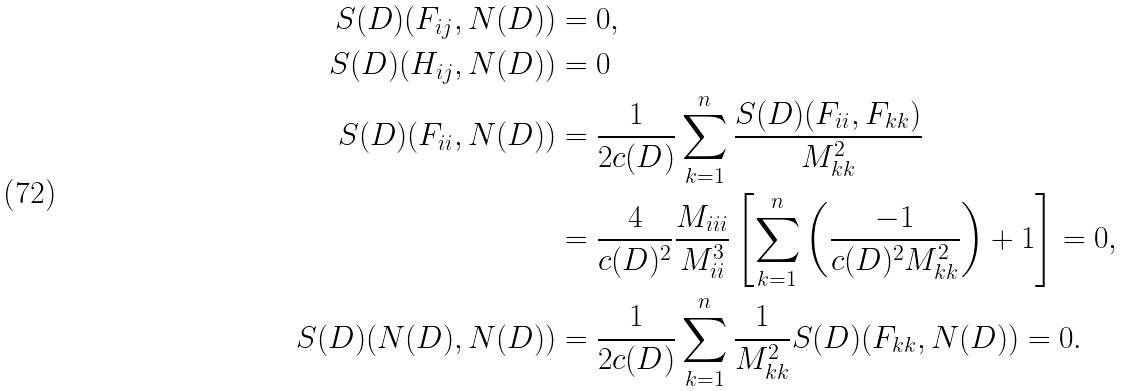<formula> <loc_0><loc_0><loc_500><loc_500>S ( D ) ( F _ { i j } , N ( D ) ) & = 0 , \\ S ( D ) ( H _ { i j } , N ( D ) ) & = 0 \\ S ( D ) ( F _ { i i } , N ( D ) ) & = \frac { 1 } { 2 c ( D ) } \sum _ { k = 1 } ^ { n } \frac { S ( D ) ( F _ { i i } , F _ { k k } ) } { M _ { k k } ^ { 2 } } \\ & = \frac { 4 } { c ( D ) ^ { 2 } } \frac { M _ { i i i } } { M _ { i i } ^ { 3 } } \left [ \sum _ { k = 1 } ^ { n } \left ( \frac { - 1 } { c ( D ) ^ { 2 } M _ { k k } ^ { 2 } } \right ) + 1 \right ] = 0 , \\ S ( D ) ( N ( D ) , N ( D ) ) & = \frac { 1 } { 2 c ( D ) } \sum _ { k = 1 } ^ { n } \frac { 1 } { M _ { k k } ^ { 2 } } S ( D ) ( F _ { k k } , N ( D ) ) = 0 .</formula> 